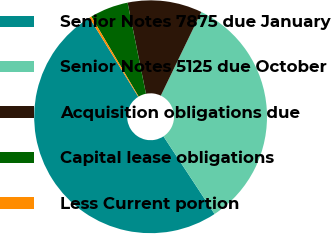Convert chart. <chart><loc_0><loc_0><loc_500><loc_500><pie_chart><fcel>Senior Notes 7875 due January<fcel>Senior Notes 5125 due October<fcel>Acquisition obligations due<fcel>Capital lease obligations<fcel>Less Current portion<nl><fcel>50.46%<fcel>33.57%<fcel>10.34%<fcel>5.33%<fcel>0.31%<nl></chart> 